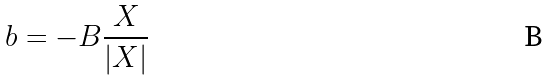<formula> <loc_0><loc_0><loc_500><loc_500>b = - B \frac { X } { | X | }</formula> 